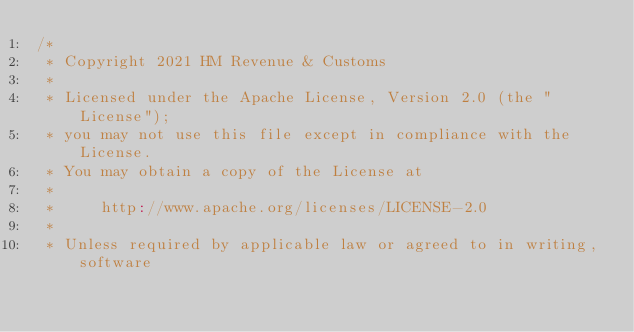<code> <loc_0><loc_0><loc_500><loc_500><_Scala_>/*
 * Copyright 2021 HM Revenue & Customs
 *
 * Licensed under the Apache License, Version 2.0 (the "License");
 * you may not use this file except in compliance with the License.
 * You may obtain a copy of the License at
 *
 *     http://www.apache.org/licenses/LICENSE-2.0
 *
 * Unless required by applicable law or agreed to in writing, software</code> 